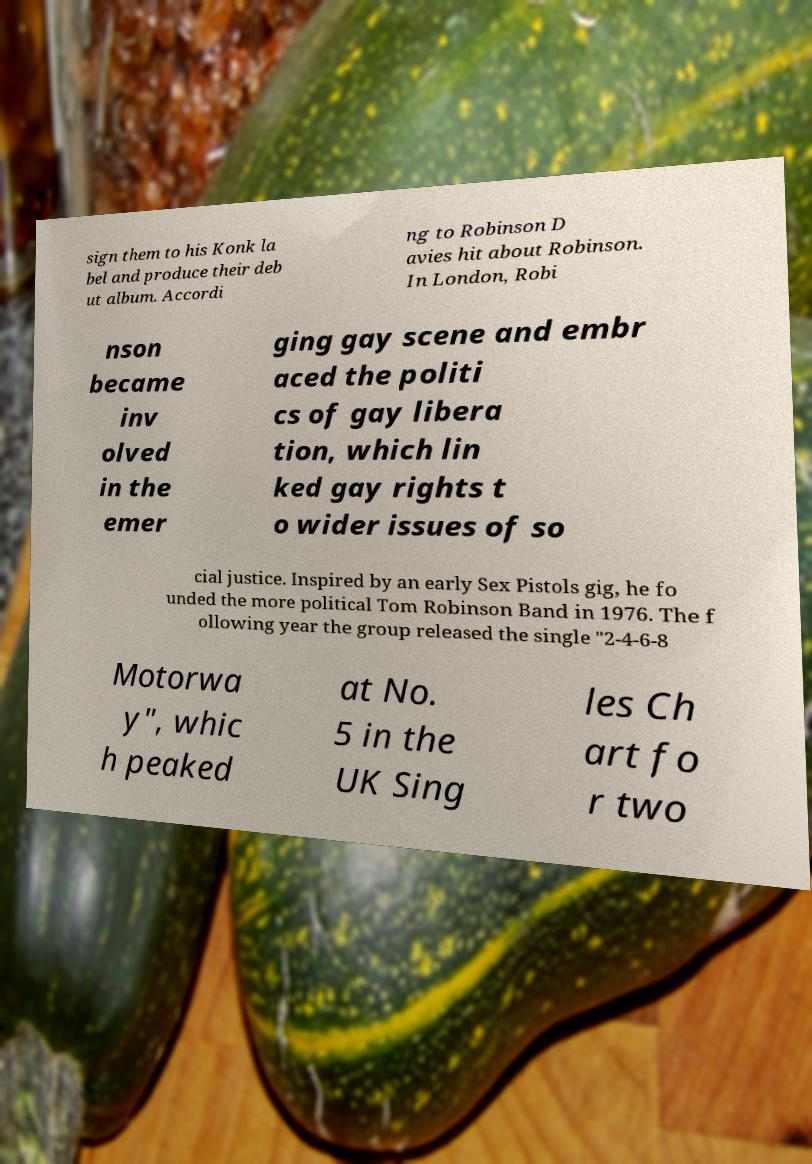Could you assist in decoding the text presented in this image and type it out clearly? sign them to his Konk la bel and produce their deb ut album. Accordi ng to Robinson D avies hit about Robinson. In London, Robi nson became inv olved in the emer ging gay scene and embr aced the politi cs of gay libera tion, which lin ked gay rights t o wider issues of so cial justice. Inspired by an early Sex Pistols gig, he fo unded the more political Tom Robinson Band in 1976. The f ollowing year the group released the single "2-4-6-8 Motorwa y", whic h peaked at No. 5 in the UK Sing les Ch art fo r two 